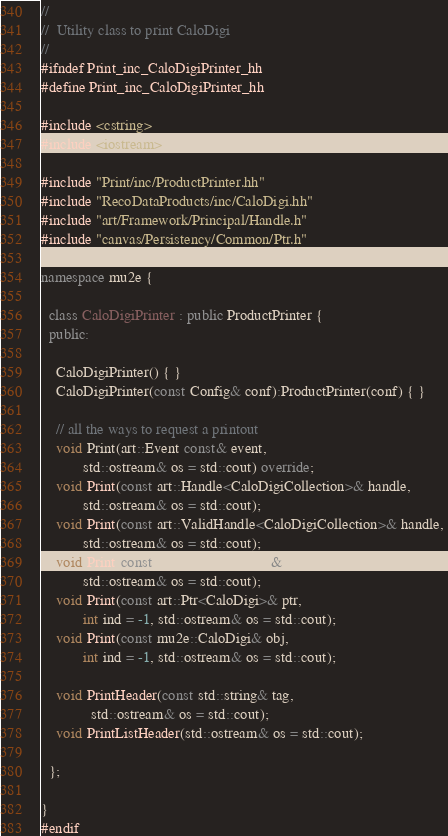Convert code to text. <code><loc_0><loc_0><loc_500><loc_500><_C++_>//
//  Utility class to print CaloDigi
// 
#ifndef Print_inc_CaloDigiPrinter_hh
#define Print_inc_CaloDigiPrinter_hh

#include <cstring>
#include <iostream>

#include "Print/inc/ProductPrinter.hh"
#include "RecoDataProducts/inc/CaloDigi.hh"
#include "art/Framework/Principal/Handle.h"
#include "canvas/Persistency/Common/Ptr.h"

namespace mu2e {

  class CaloDigiPrinter : public ProductPrinter {
  public:

    CaloDigiPrinter() { }
    CaloDigiPrinter(const Config& conf):ProductPrinter(conf) { }

    // all the ways to request a printout
    void Print(art::Event const& event,
	       std::ostream& os = std::cout) override;
    void Print(const art::Handle<CaloDigiCollection>& handle, 
	       std::ostream& os = std::cout);
    void Print(const art::ValidHandle<CaloDigiCollection>& handle, 
	       std::ostream& os = std::cout);
    void Print(const CaloDigiCollection& coll, 
	       std::ostream& os = std::cout);
    void Print(const art::Ptr<CaloDigi>& ptr, 
	       int ind = -1, std::ostream& os = std::cout);
    void Print(const mu2e::CaloDigi& obj, 
	       int ind = -1, std::ostream& os = std::cout);

    void PrintHeader(const std::string& tag, 
		     std::ostream& os = std::cout);
    void PrintListHeader(std::ostream& os = std::cout);

  };

}
#endif
</code> 